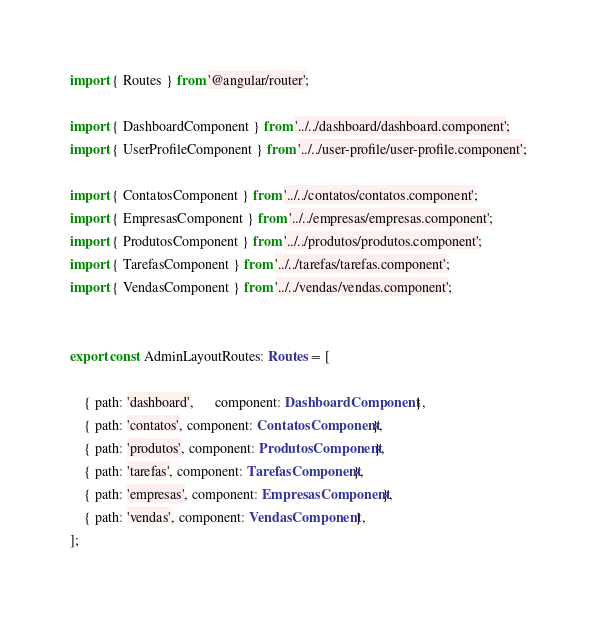Convert code to text. <code><loc_0><loc_0><loc_500><loc_500><_TypeScript_>import { Routes } from '@angular/router';

import { DashboardComponent } from '../../dashboard/dashboard.component';
import { UserProfileComponent } from '../../user-profile/user-profile.component';

import { ContatosComponent } from '../../contatos/contatos.component';
import { EmpresasComponent } from '../../empresas/empresas.component';
import { ProdutosComponent } from '../../produtos/produtos.component';
import { TarefasComponent } from '../../tarefas/tarefas.component';
import { VendasComponent } from '../../vendas/vendas.component';


export const AdminLayoutRoutes: Routes = [
   
    { path: 'dashboard',      component: DashboardComponent },
    { path: 'contatos', component: ContatosComponent},
    { path: 'produtos', component: ProdutosComponent},
    { path: 'tarefas', component: TarefasComponent},
    { path: 'empresas', component: EmpresasComponent},
    { path: 'vendas', component: VendasComponent},
];
</code> 